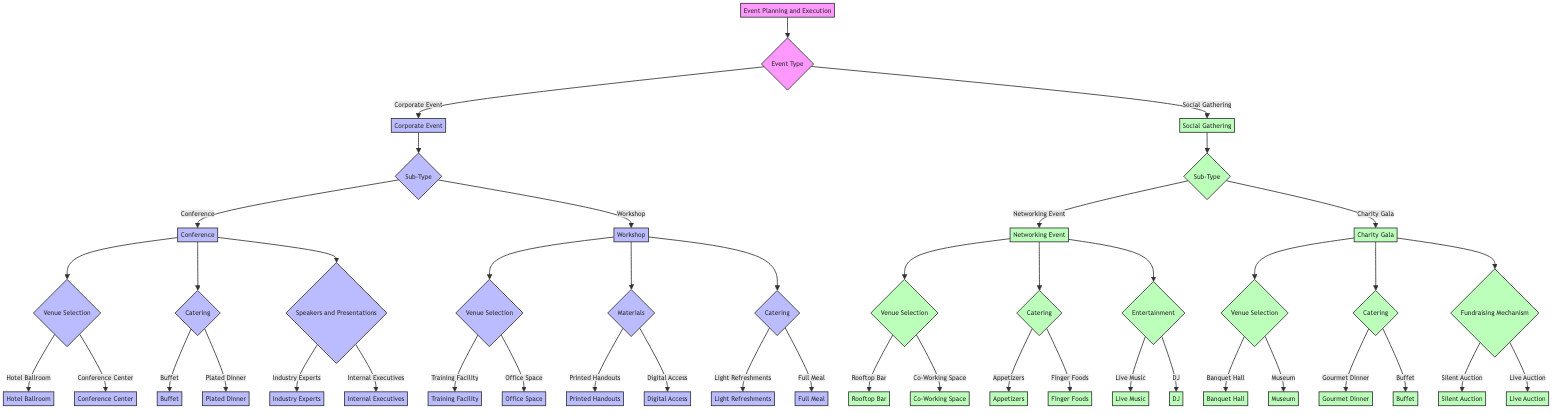What are the two main types of events in the diagram? The diagram shows two main event types that stem from the initial decision node: "Corporate Event" and "Social Gathering".
Answer: Corporate Event, Social Gathering How many sub-types are available under the Corporate Event category? Under the Corporate Event category, there are two defined sub-types indicated in the diagram: "Conference" and "Workshop".
Answer: 2 What catering options are available for the Workshop sub-type? According to the diagram, the Workshop offers two catering options: "Light Refreshments" and "Full Meal".
Answer: Light Refreshments, Full Meal Which venue selection option is available for the Networking Event? The Networking Event provides two venue selection options: "Rooftop Bar" and "Co-Working Space".
Answer: Rooftop Bar, Co-Working Space What fundraising mechanisms are provided for the Charity Gala? The Charity Gala contains two fundraising mechanisms, as illustrated in the diagram: "Silent Auction" and "Live Auction".
Answer: Silent Auction, Live Auction What type of entertainment options are available for the Networking Event? The diagram specifies two entertainment options available for the Networking Event: "Live Music" and "DJ".
Answer: Live Music, DJ If you choose a Conference and want a plated dinner, what are the next steps for venue selection? After deciding on a Conference and a plated dinner, the next step is to choose between the venue selections of "Hotel Ballroom" and "Conference Center".
Answer: Hotel Ballroom, Conference Center Which speaker option is associated with the Conference sub-type? The Conference sub-type allows for speaker options including "Industry Experts" and "Internal Executives".
Answer: Industry Experts, Internal Executives What are the two main categories of event types illustrated in this decision tree? The decision tree delineates two major categories for events: "Corporate Event" and "Social Gathering".
Answer: Corporate Event, Social Gathering 